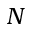Convert formula to latex. <formula><loc_0><loc_0><loc_500><loc_500>N</formula> 